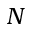Convert formula to latex. <formula><loc_0><loc_0><loc_500><loc_500>N</formula> 